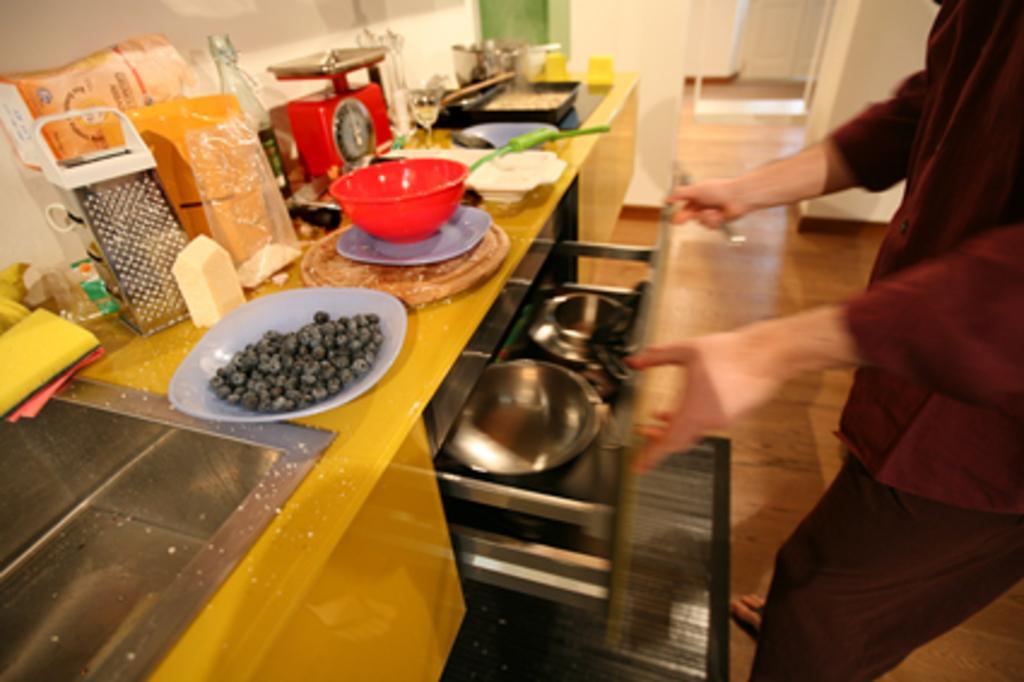Describe this image in one or two sentences. In this image I can see a person holding the rack. I can see a food in plate. I can see a bowl,plate,tray,vessels and few objects on the table. Back I can see the white wall. 